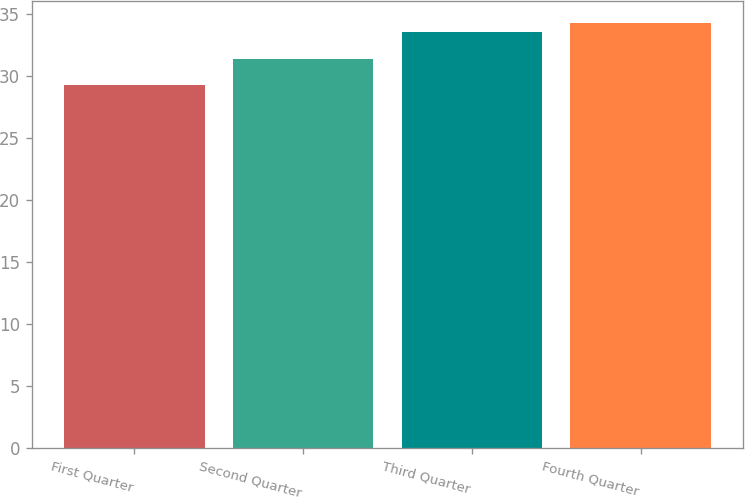Convert chart. <chart><loc_0><loc_0><loc_500><loc_500><bar_chart><fcel>First Quarter<fcel>Second Quarter<fcel>Third Quarter<fcel>Fourth Quarter<nl><fcel>29.3<fcel>31.39<fcel>33.55<fcel>34.32<nl></chart> 